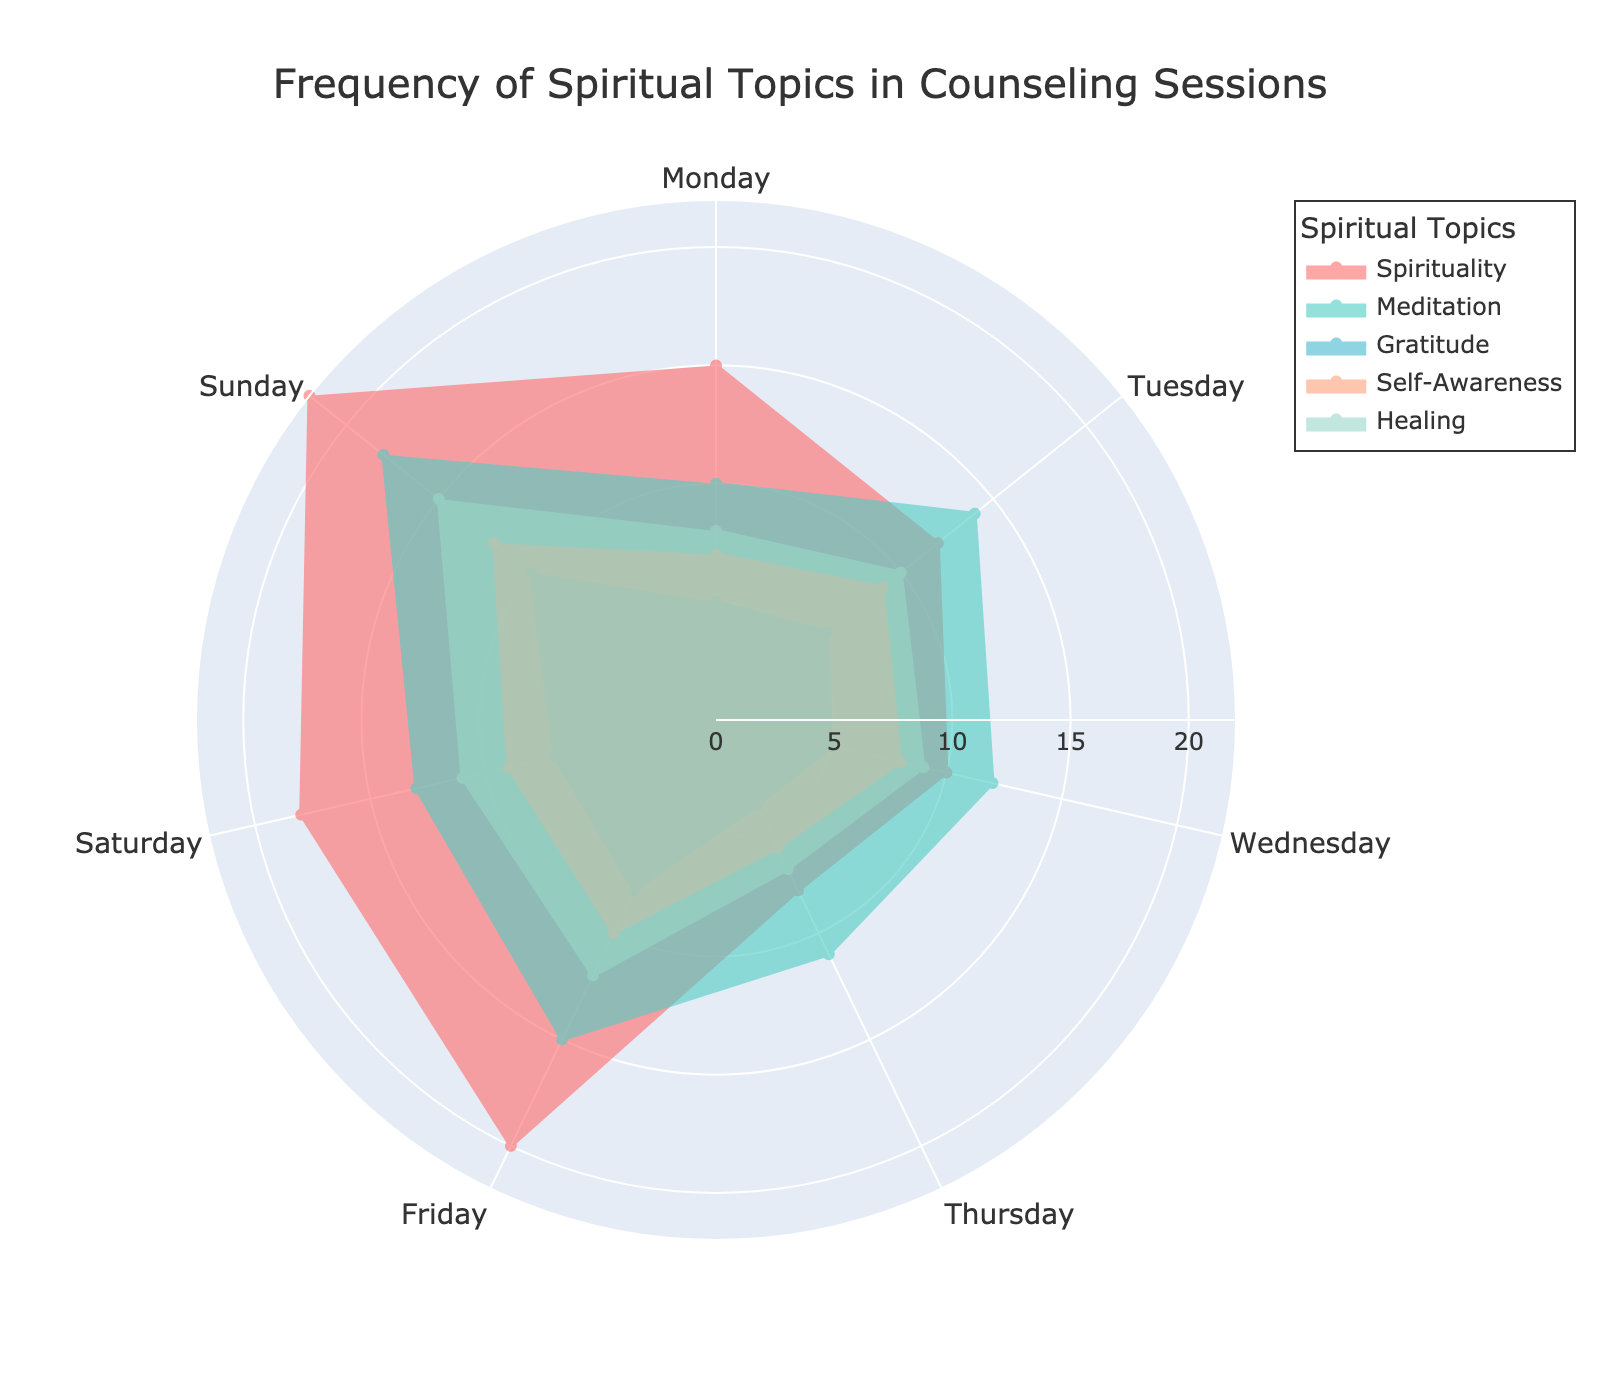What's the title of the figure? Look at the top section of the figure to find the title. The title is usually prominently placed for easy identification.
Answer: Frequency of Spiritual Topics in Counseling Sessions Which days have the lowest frequency for the "Gratitude" topic? Check the radial values for the "Gratitude" topic on each day. Identify the lowest values.
Answer: Thursday and Wednesday What is the overall highest frequency recorded for any spiritual topic, and on which day it occurs? Examine the maximum radial values for each spiritual topic across all days. The highest overall frequency is the peak value.
Answer: 22 on Sunday for Spirituality How does the frequency of "Meditation" on Tuesday compare to that on Thursday? Locate the radial values representing the "Meditation" topic for Tuesday and Thursday, then compare the two values.
Answer: Tuesday has a higher frequency (14) than Thursday (11) What is the average frequency of "Healing" for the weekend (Saturday and Sunday)? Add the frequencies of "Healing" on Saturday and Sunday and divide by the number of days (2). Calculation: (11 + 15) / 2 = 13
Answer: 13 On which day is "Self-Awareness" discussed the least, and how frequently does it occur? Identify the lowest radial value for "Self-Awareness" across all days, then determine the corresponding day.
Answer: Thursday with a frequency of 6 Which topic has the most balanced frequency throughout the week? Compare the variation in radial values of each topic over the week. The topic with the smallest range between its maximum and minimum values is the most balanced.
Answer: Gratitude Is there any day where all topics have frequencies above 5? Check the radial values for all topics on each day and see if there are any days where all values are greater than 5.
Answer: Yes, Sunday What is the total frequency of "Spirituality" from Monday to Friday? Add the frequencies of "Spirituality" for Monday through Friday. Calculation: 15 + 12 + 10 + 8 + 20 = 65
Answer: 65 On which day is the difference between "Spirituality" and "Meditation" the highest? For each day, calculate the absolute difference between the frequencies of "Spirituality" and "Meditation" and identify the maximum difference.
Answer: Sunday (difference is 4) 